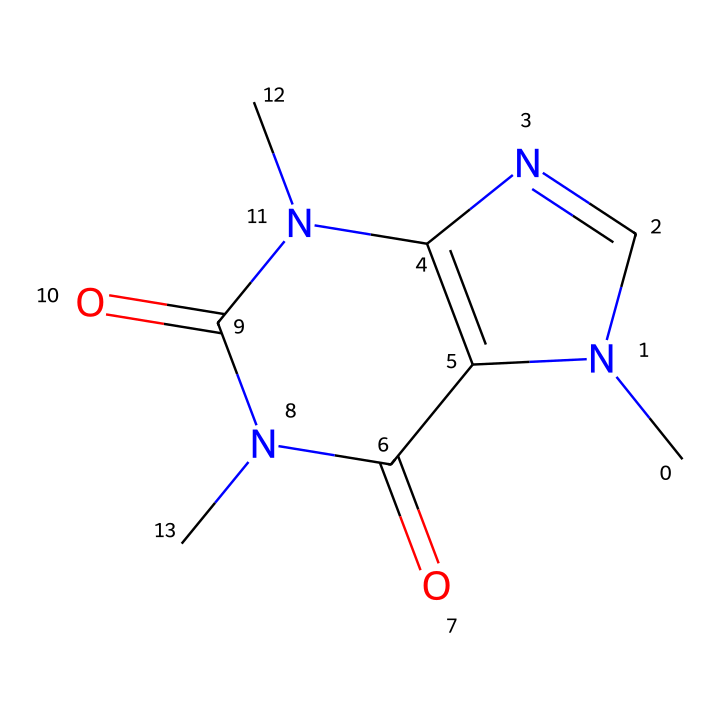What is the molecular formula of this chemical? To find the molecular formula, we count the atoms of each element in the SMILES representation. The structure contains 8 carbon (C) atoms, 10 hydrogen (H) atoms, 4 nitrogen (N) atoms, and 2 oxygen (O) atoms. Thus, the molecular formula is C8H10N4O2.
Answer: C8H10N4O2 How many nitrogen atoms are present in the structure? By analyzing the SMILES, we can identify that there are four nitrogen (N) atoms in the structure. We count the occurrences of the 'N' character, which reveals that it appears four times.
Answer: 4 What type of drug is caffeine categorized as? Caffeine is classified as a stimulant, particularly an alkaloid, due to its physiological effects that enhance alertness and reduce fatigue. Furthermore, the presence of nitrogen atoms is characteristic of alkaloids.
Answer: stimulant What is the primary effect of caffeine on the human body? The primary effect of caffeine in the human body is to increase alertness. This is due to its ability to block adenosine receptors, leading to heightened neuronal activity and wakefulness.
Answer: alertness Which functional groups are present in caffeine? The SMILES representation indicates that caffeine contains amine (from the nitrogen atoms) and carbonyl (from the oxygen and carbon arrangements) functional groups. These groups contribute to its chemical reactivity and its classification as a methylxanthine.
Answer: amine and carbonyl 